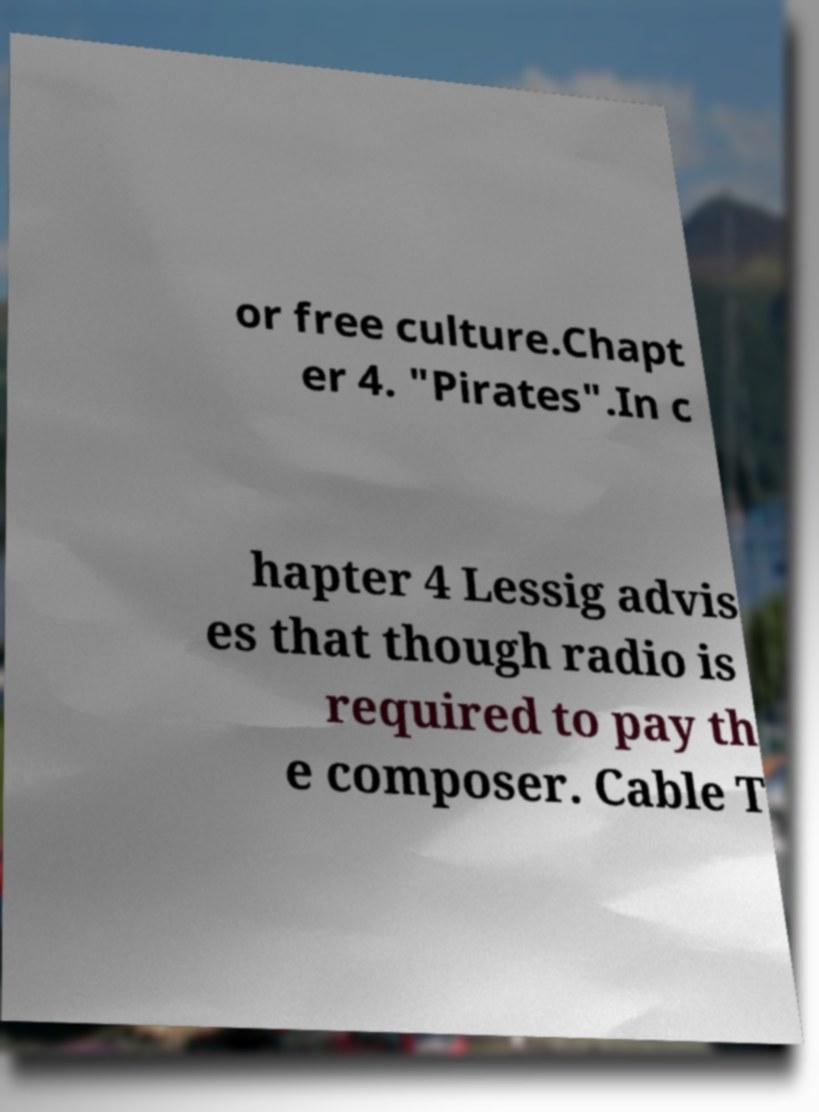Can you accurately transcribe the text from the provided image for me? or free culture.Chapt er 4. "Pirates".In c hapter 4 Lessig advis es that though radio is required to pay th e composer. Cable T 